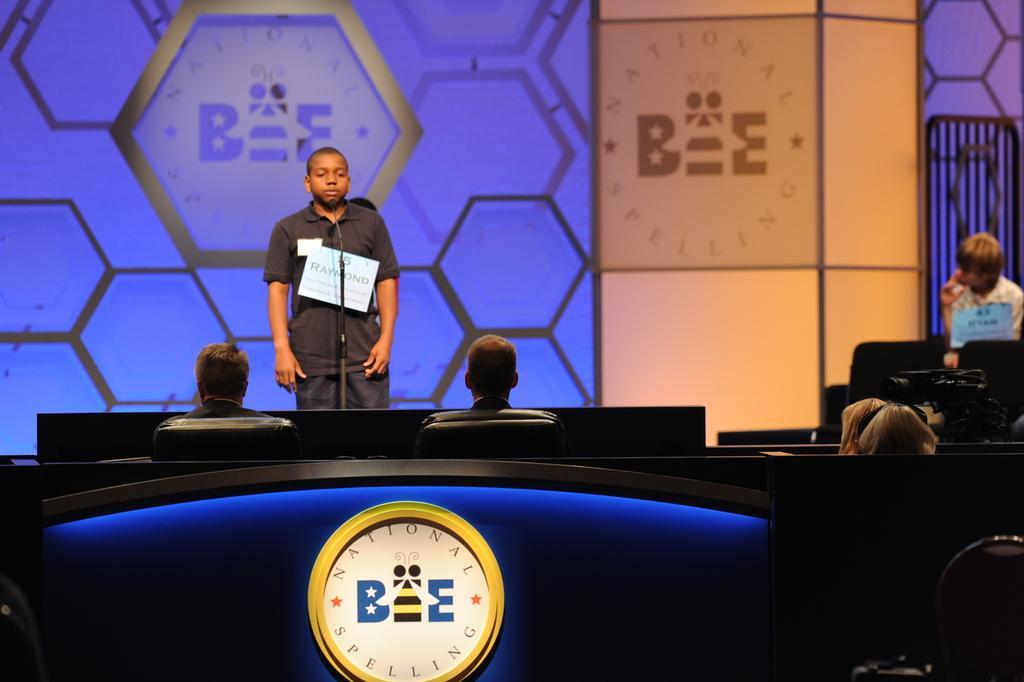In one or two sentences, can you explain what this image depicts? The man in the middle of the picture wearing black shirt is standing in front of the microphone. In front of him, we see two men sitting on the chairs. Beside them, we see two women are also sitting on the chairs. At the bottom of the picture, we see a board on which "National Spelling Bee" is written is placed on the blue color sheet. On the right side, we see the man in white T-shirt is sitting on the chair. Beside him, we see a white pillar and in the background, it is blue in color. This picture might be clicked in the auditorium. 